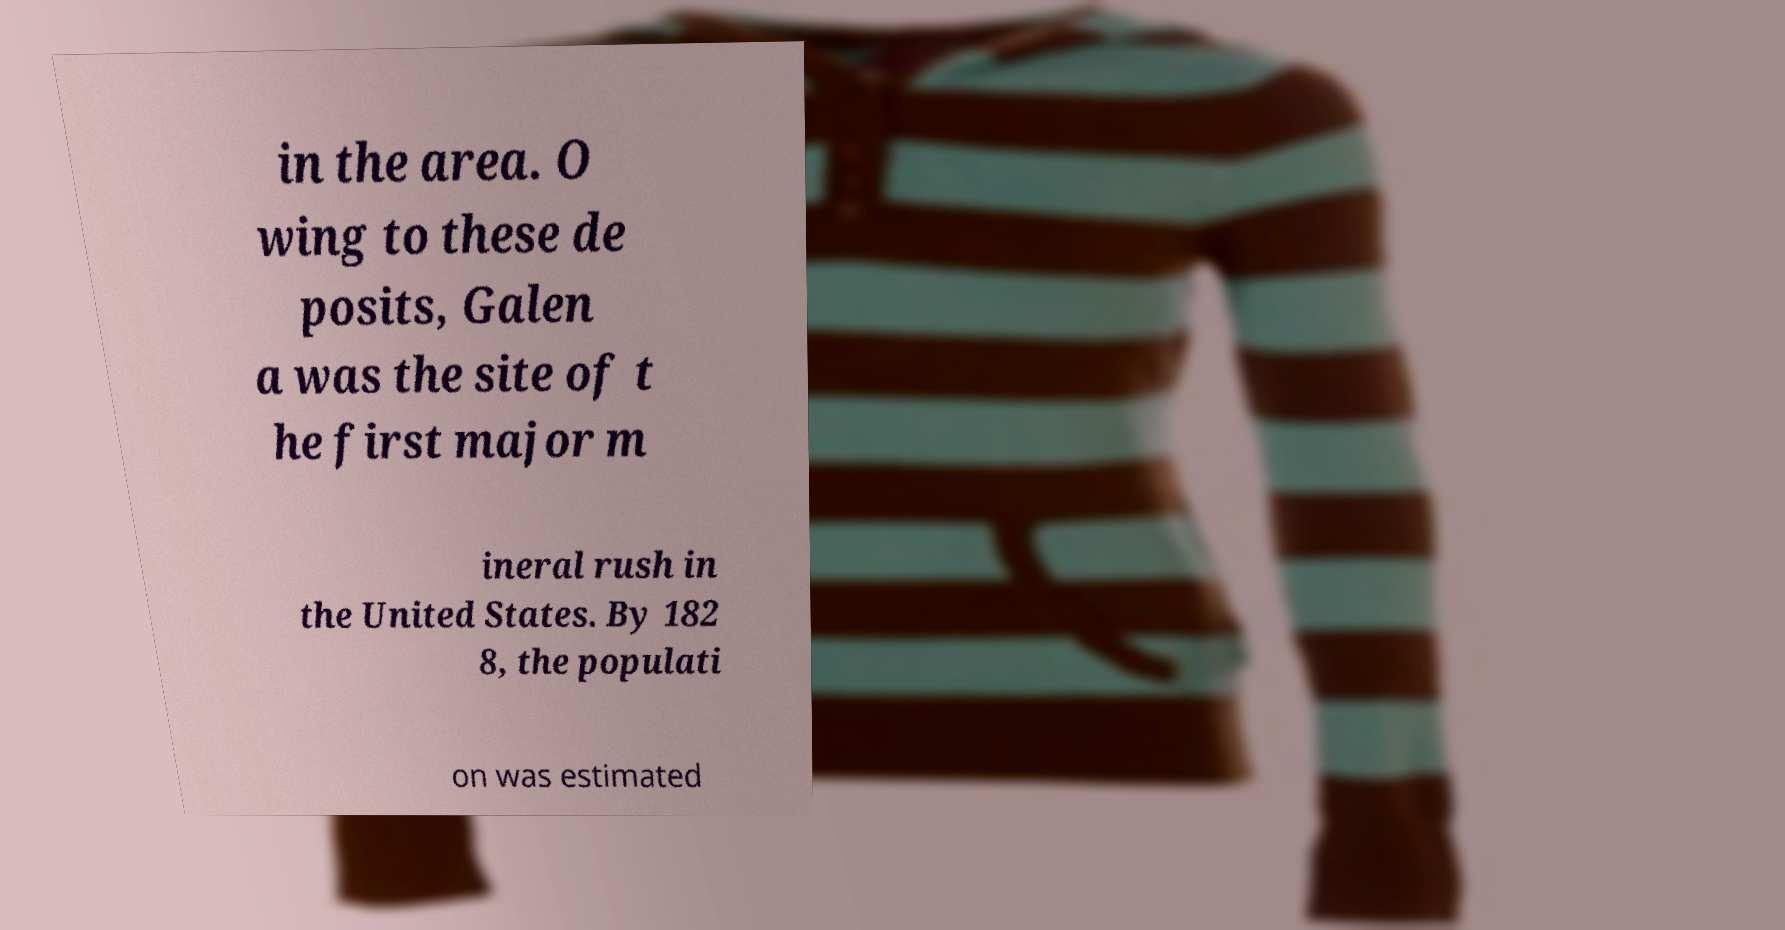What messages or text are displayed in this image? I need them in a readable, typed format. in the area. O wing to these de posits, Galen a was the site of t he first major m ineral rush in the United States. By 182 8, the populati on was estimated 